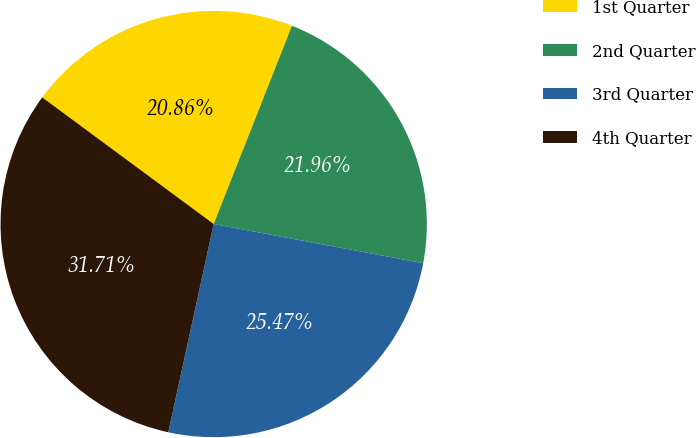Convert chart. <chart><loc_0><loc_0><loc_500><loc_500><pie_chart><fcel>1st Quarter<fcel>2nd Quarter<fcel>3rd Quarter<fcel>4th Quarter<nl><fcel>20.86%<fcel>21.96%<fcel>25.47%<fcel>31.71%<nl></chart> 